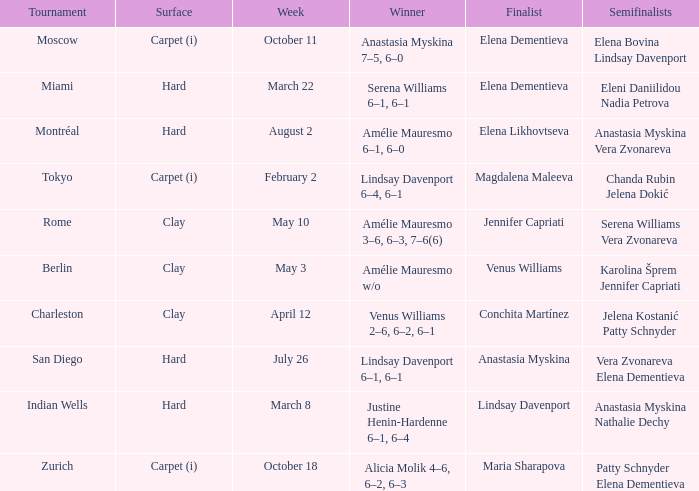Who were the semifinalists in the Rome tournament? Serena Williams Vera Zvonareva. 